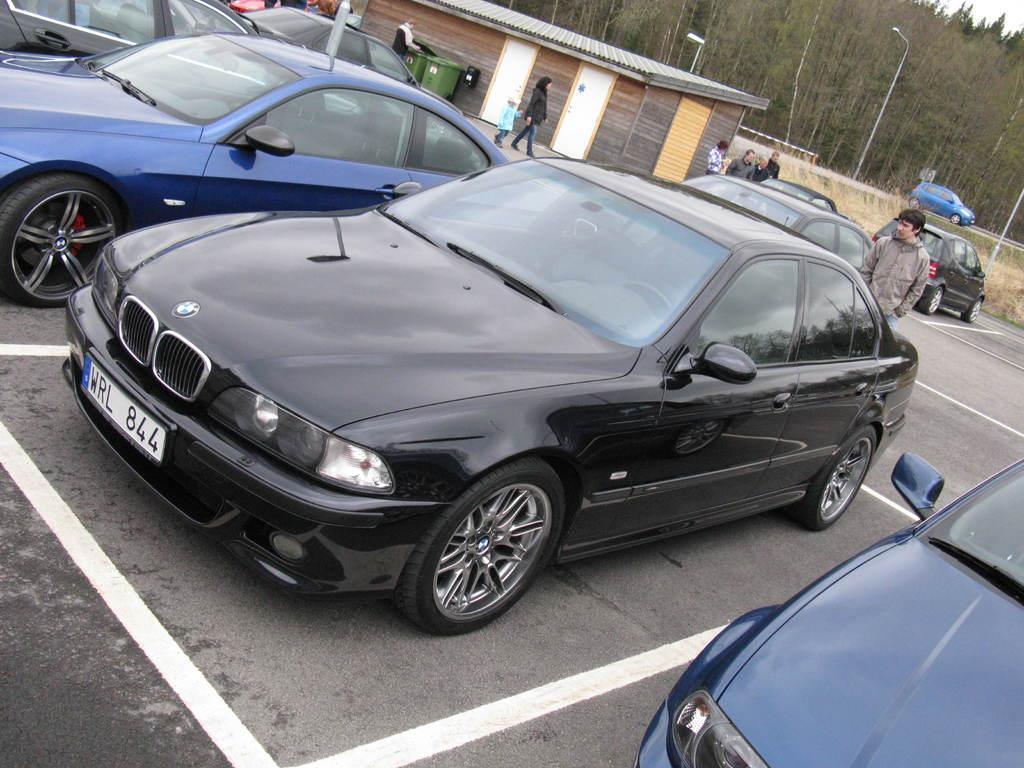Please provide a concise description of this image. In this image in the center there are some vehicles, and in the background there are some people are walking and there are some houses, dustbin, wall, poles, trees. And at the bottom there is road. 